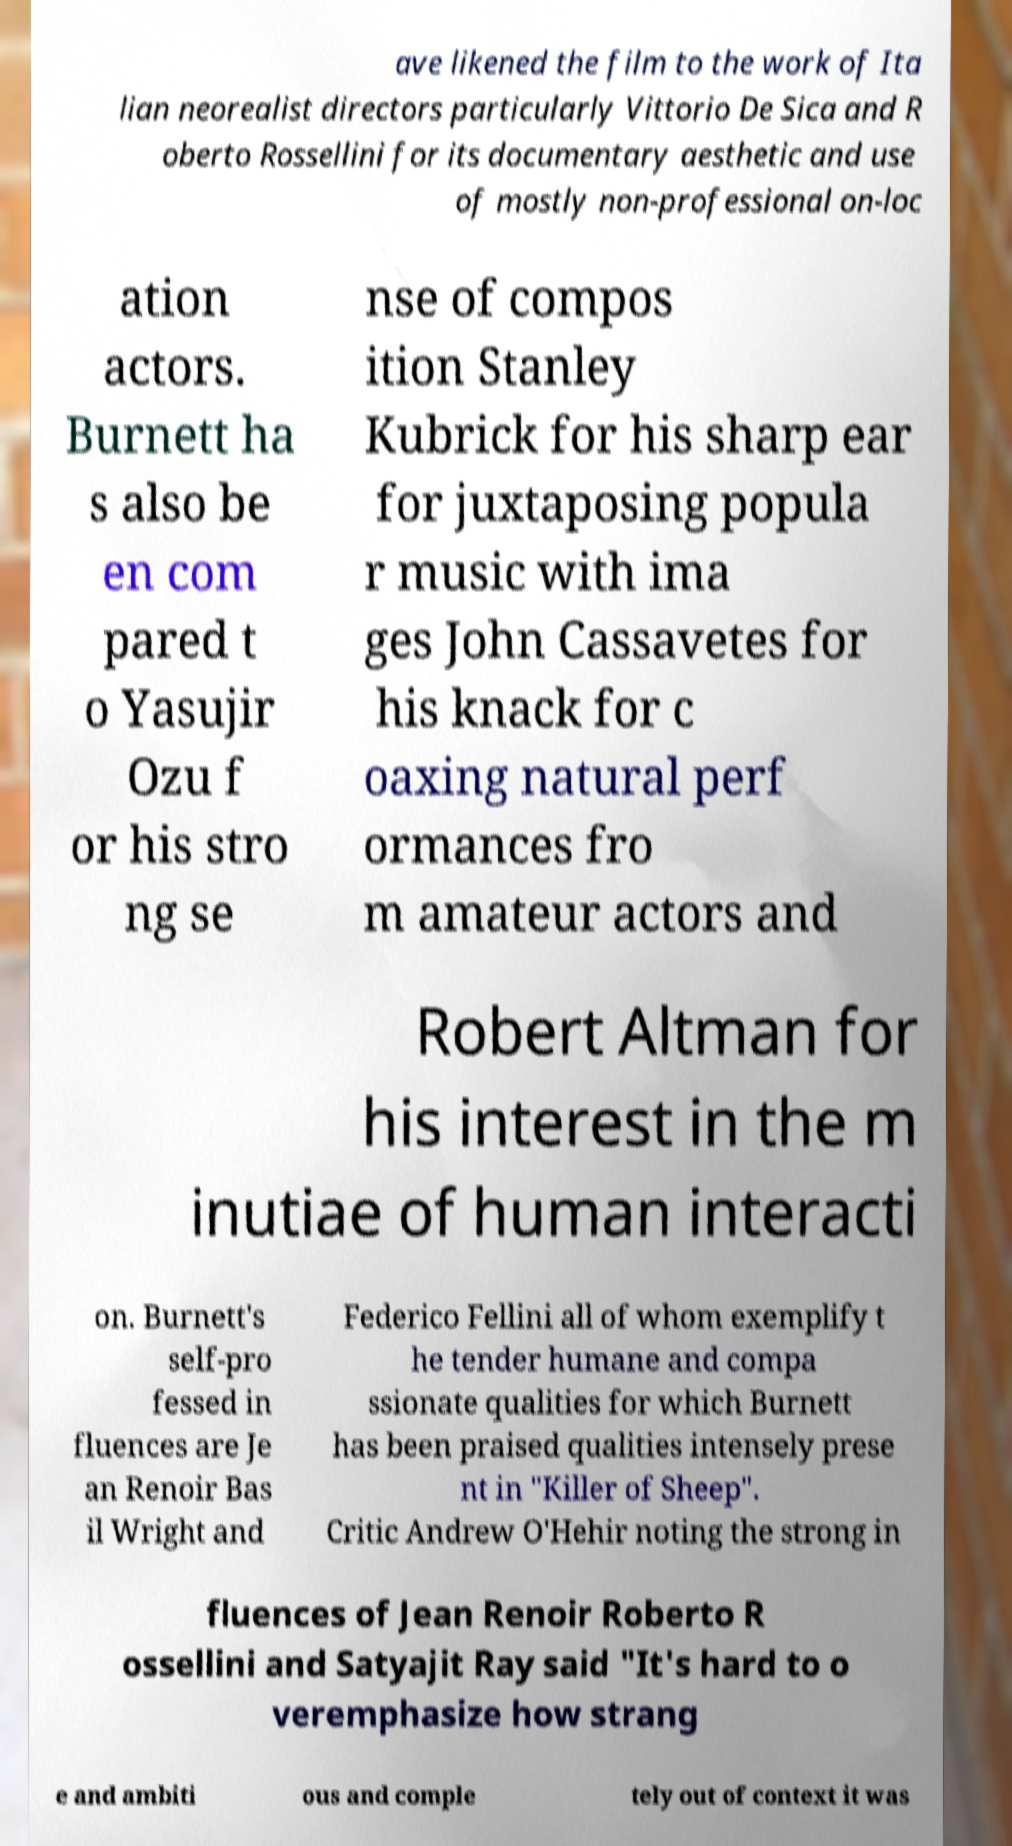Could you extract and type out the text from this image? ave likened the film to the work of Ita lian neorealist directors particularly Vittorio De Sica and R oberto Rossellini for its documentary aesthetic and use of mostly non-professional on-loc ation actors. Burnett ha s also be en com pared t o Yasujir Ozu f or his stro ng se nse of compos ition Stanley Kubrick for his sharp ear for juxtaposing popula r music with ima ges John Cassavetes for his knack for c oaxing natural perf ormances fro m amateur actors and Robert Altman for his interest in the m inutiae of human interacti on. Burnett's self-pro fessed in fluences are Je an Renoir Bas il Wright and Federico Fellini all of whom exemplify t he tender humane and compa ssionate qualities for which Burnett has been praised qualities intensely prese nt in "Killer of Sheep". Critic Andrew O'Hehir noting the strong in fluences of Jean Renoir Roberto R ossellini and Satyajit Ray said "It's hard to o veremphasize how strang e and ambiti ous and comple tely out of context it was 